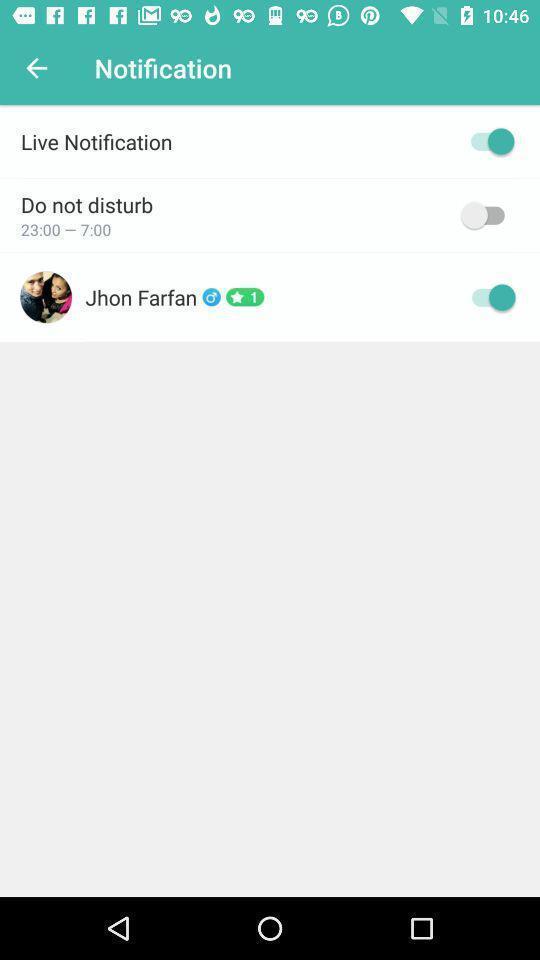Give me a summary of this screen capture. Page for the video chat app with other options. 